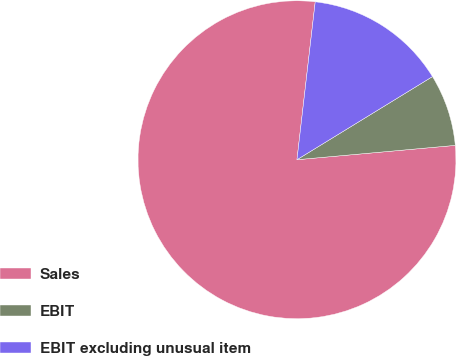<chart> <loc_0><loc_0><loc_500><loc_500><pie_chart><fcel>Sales<fcel>EBIT<fcel>EBIT excluding unusual item<nl><fcel>78.27%<fcel>7.32%<fcel>14.41%<nl></chart> 